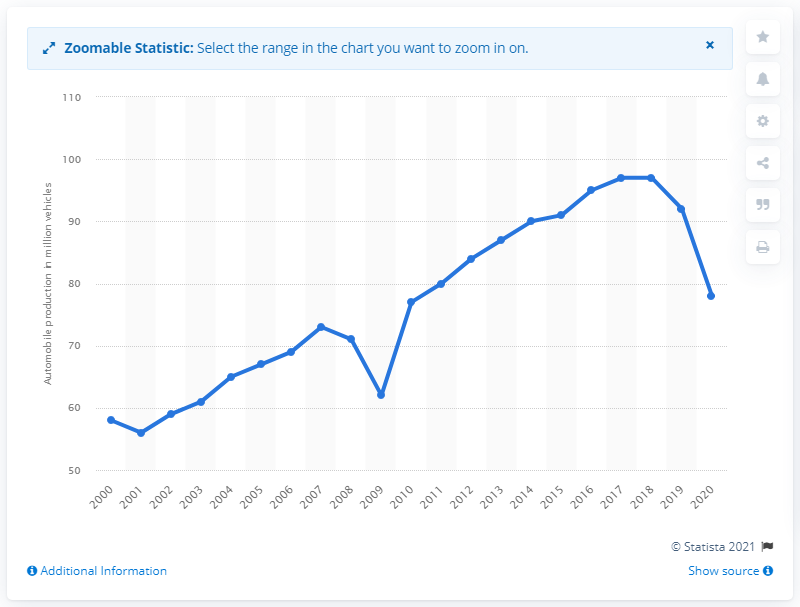Specify some key components in this picture. In 2020, a total of 78 million motor vehicles were produced worldwide. 